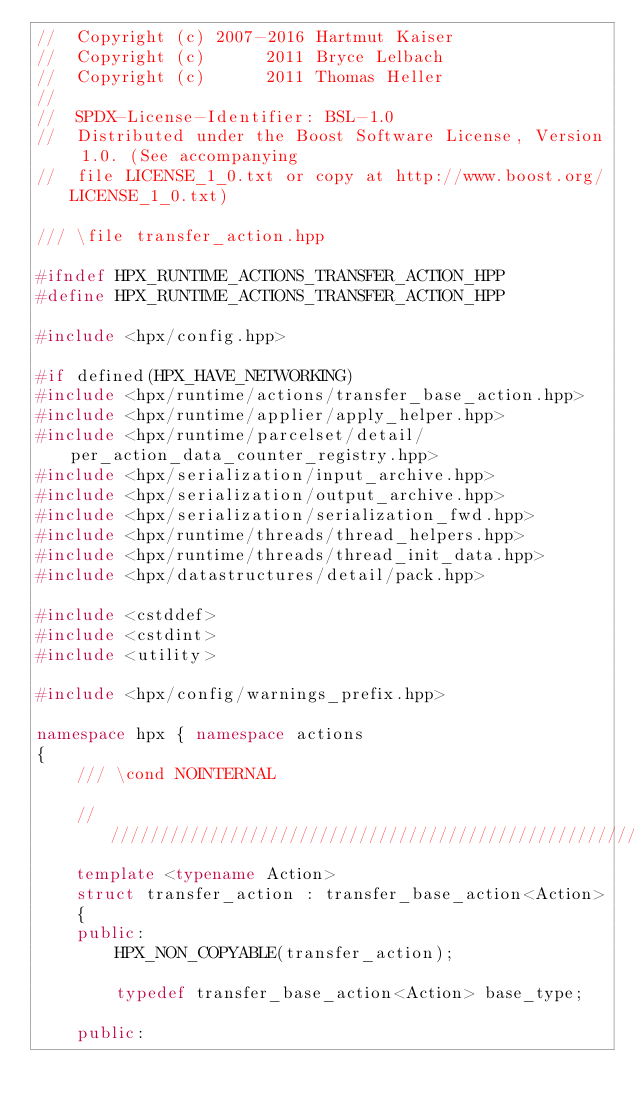<code> <loc_0><loc_0><loc_500><loc_500><_C++_>//  Copyright (c) 2007-2016 Hartmut Kaiser
//  Copyright (c)      2011 Bryce Lelbach
//  Copyright (c)      2011 Thomas Heller
//
//  SPDX-License-Identifier: BSL-1.0
//  Distributed under the Boost Software License, Version 1.0. (See accompanying
//  file LICENSE_1_0.txt or copy at http://www.boost.org/LICENSE_1_0.txt)

/// \file transfer_action.hpp

#ifndef HPX_RUNTIME_ACTIONS_TRANSFER_ACTION_HPP
#define HPX_RUNTIME_ACTIONS_TRANSFER_ACTION_HPP

#include <hpx/config.hpp>

#if defined(HPX_HAVE_NETWORKING)
#include <hpx/runtime/actions/transfer_base_action.hpp>
#include <hpx/runtime/applier/apply_helper.hpp>
#include <hpx/runtime/parcelset/detail/per_action_data_counter_registry.hpp>
#include <hpx/serialization/input_archive.hpp>
#include <hpx/serialization/output_archive.hpp>
#include <hpx/serialization/serialization_fwd.hpp>
#include <hpx/runtime/threads/thread_helpers.hpp>
#include <hpx/runtime/threads/thread_init_data.hpp>
#include <hpx/datastructures/detail/pack.hpp>

#include <cstddef>
#include <cstdint>
#include <utility>

#include <hpx/config/warnings_prefix.hpp>

namespace hpx { namespace actions
{
    /// \cond NOINTERNAL

    ///////////////////////////////////////////////////////////////////////////
    template <typename Action>
    struct transfer_action : transfer_base_action<Action>
    {
    public:
        HPX_NON_COPYABLE(transfer_action);

        typedef transfer_base_action<Action> base_type;

    public:</code> 